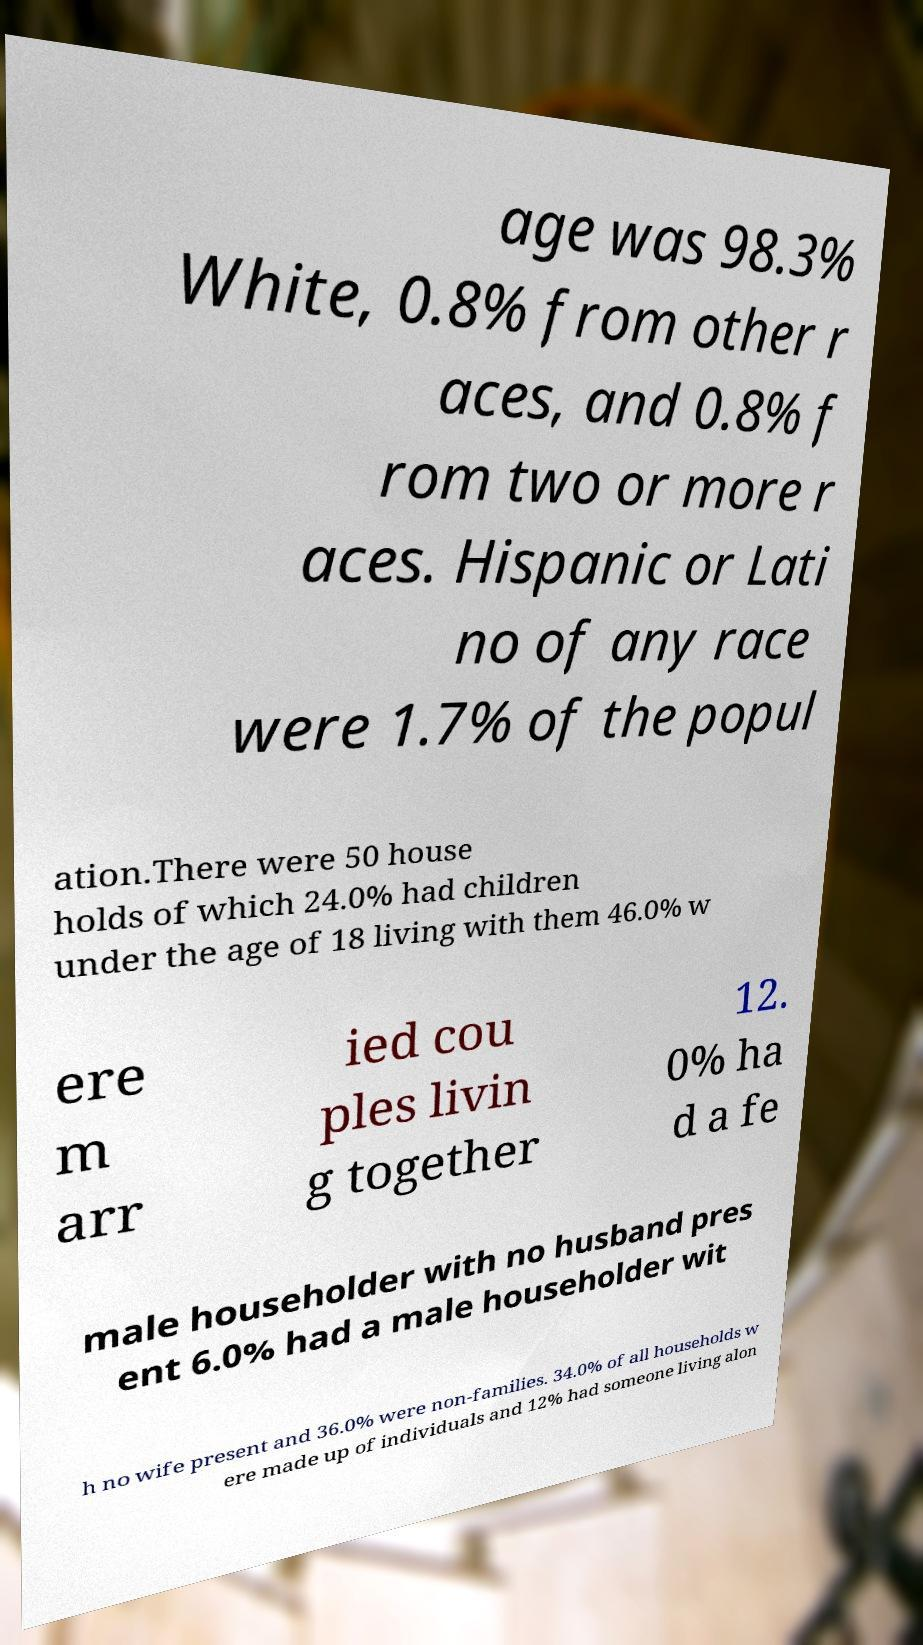For documentation purposes, I need the text within this image transcribed. Could you provide that? age was 98.3% White, 0.8% from other r aces, and 0.8% f rom two or more r aces. Hispanic or Lati no of any race were 1.7% of the popul ation.There were 50 house holds of which 24.0% had children under the age of 18 living with them 46.0% w ere m arr ied cou ples livin g together 12. 0% ha d a fe male householder with no husband pres ent 6.0% had a male householder wit h no wife present and 36.0% were non-families. 34.0% of all households w ere made up of individuals and 12% had someone living alon 